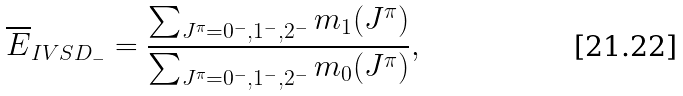<formula> <loc_0><loc_0><loc_500><loc_500>\overline { E } _ { I V S D _ { - } } = \frac { \sum _ { J ^ { \pi } = 0 ^ { - } , 1 ^ { - } , 2 ^ { - } } m _ { 1 } ( J ^ { \pi } ) } { \sum _ { J ^ { \pi } = 0 ^ { - } , 1 ^ { - } , 2 ^ { - } } m _ { 0 } ( J ^ { \pi } ) } ,</formula> 